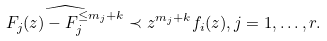Convert formula to latex. <formula><loc_0><loc_0><loc_500><loc_500>\widehat { F _ { j } ( z ) - F _ { j } ^ { \leq m _ { j } + k } } \prec z ^ { m _ { j } + k } f _ { i } ( z ) , j = 1 , \dots , r .</formula> 